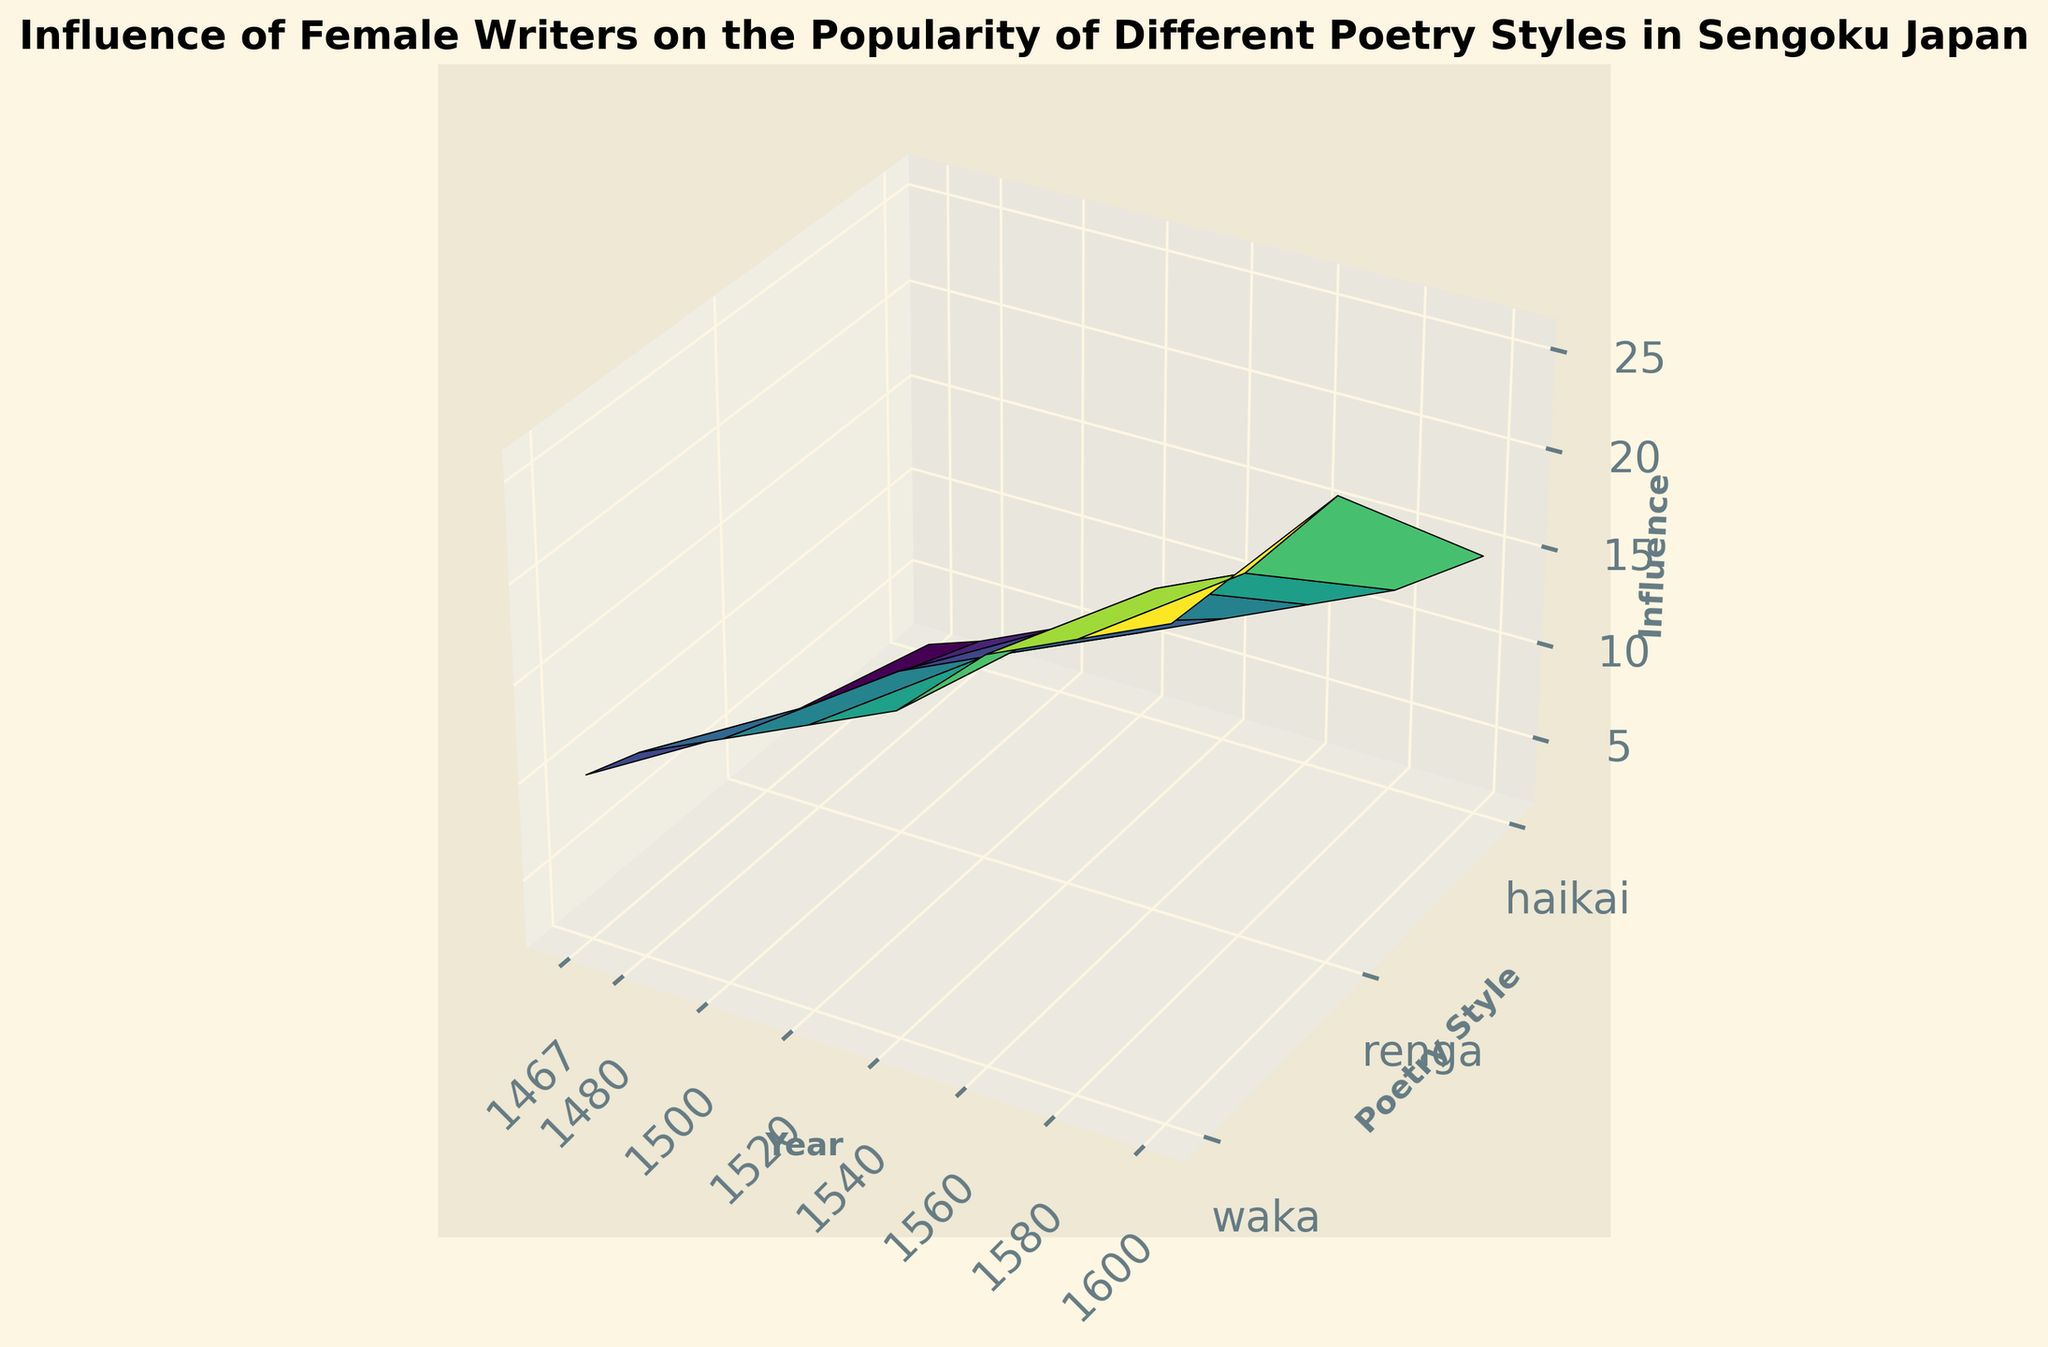Which poetry style had the highest influence in the year 1600? By examining the height of the surface plot in the year 1600 for each poetry style, we can compare the values directly. The "waka" style has the highest peak.
Answer: waka Which poetry style showed the most significant increase in influence from 1467 to 1600? To determine which poetry style had the most significant increase, compare the difference between the influence values in 1600 and 1467 for each style. "renga" increased from 5 to 25, "waka" increased from 10 to 26, and "haikai" increased from 2 to 15. "renga" shows the highest increase of 20.
Answer: renga What is the average influence of the "waka" style over the years shown? Sum the influence values for "waka" across all years and divide by the number of years. (10 + 12 + 14 + 16 + 18 + 22 + 24 + 26) / 8 = 17.75.
Answer: 17.75 Compare the influence of "renga" and "haikai" in the year 1500. Which one had a higher influence? Look at the surface plot for the year 1500 for both "renga" and "haikai". The "renga" surface is higher than "haikai".
Answer: renga How did the influence of "haikai" change from 1540 to 1580? Compare the heights on the surface plot for "haikai" in 1540 and 1580. The influence increased from 8 to 12.
Answer: increased What is the total influence for all poetry styles in the year 1520? Add the influence values for "waka", "renga", and "haikai" in 1520. 16 (waka) + 12 (renga) + 6 (haikai) = 34.
Answer: 34 Which year had the smallest influence for "waka"? By looking at the lowest height of the "waka" surface, we determine that the smallest value is at the year 1467.
Answer: 1467 Does the influence of "renga" at 1560 surpass the influence of "waka" at 1500? Compare the heights of "renga" at 1560 and "waka" at 1500. "renga" at 1560 has an influence of 18, which is higher than "waka's" 14 at 1500.
Answer: yes 